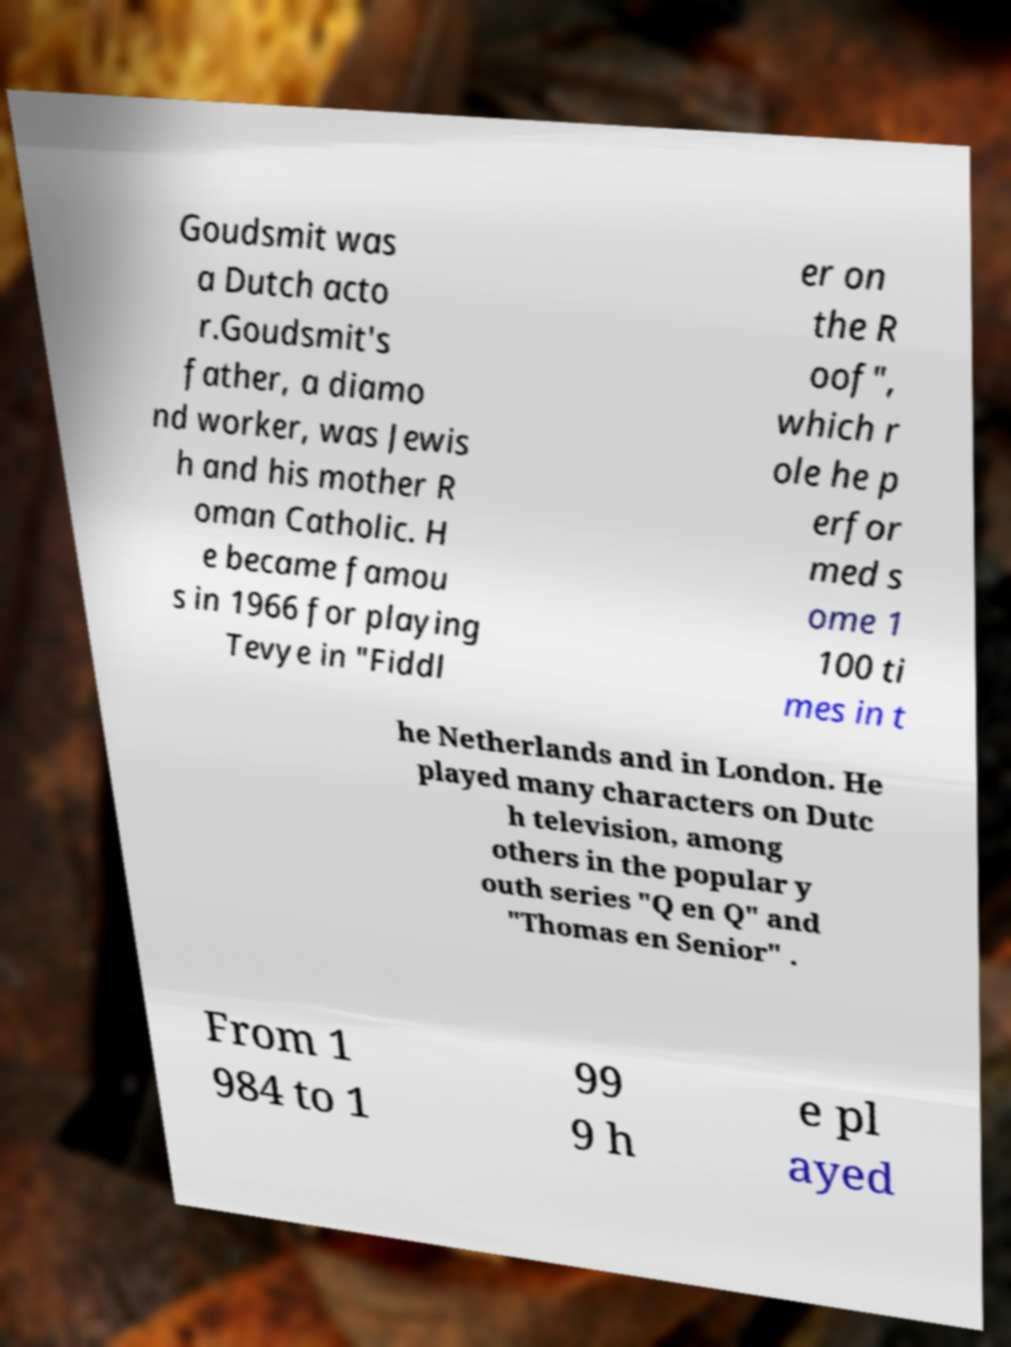What messages or text are displayed in this image? I need them in a readable, typed format. Goudsmit was a Dutch acto r.Goudsmit's father, a diamo nd worker, was Jewis h and his mother R oman Catholic. H e became famou s in 1966 for playing Tevye in "Fiddl er on the R oof", which r ole he p erfor med s ome 1 100 ti mes in t he Netherlands and in London. He played many characters on Dutc h television, among others in the popular y outh series "Q en Q" and "Thomas en Senior" . From 1 984 to 1 99 9 h e pl ayed 